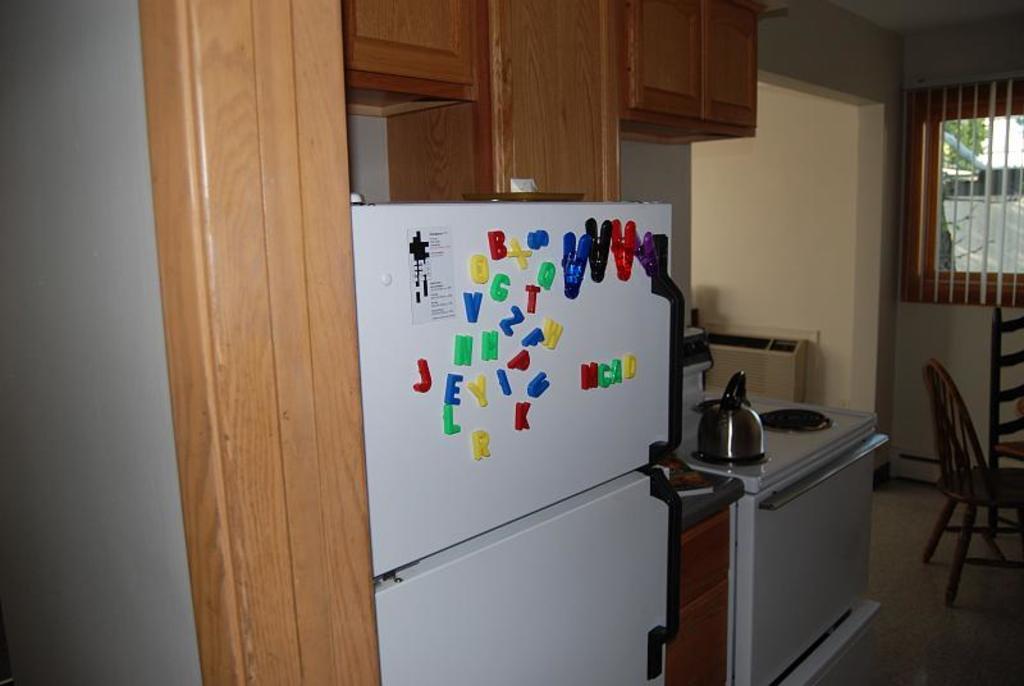Can all of the alphabet be found on the icebox?
Keep it short and to the point. Yes. What is the left-most red letter?
Make the answer very short. J. 